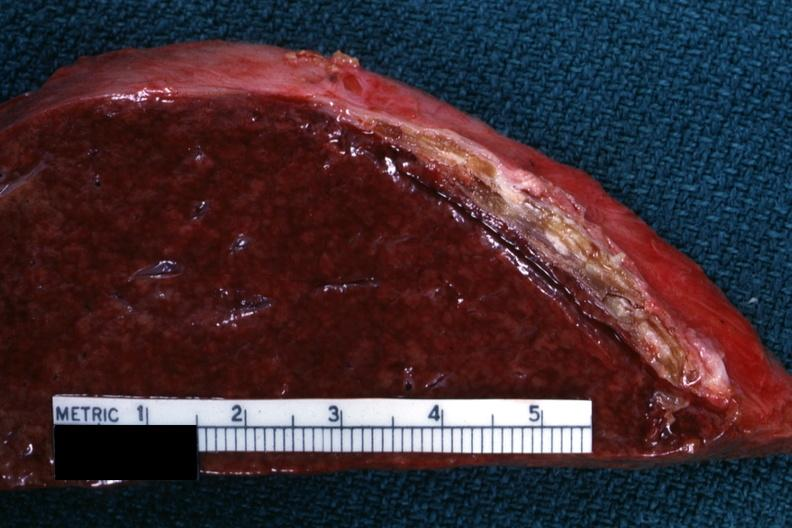s hematologic present?
Answer the question using a single word or phrase. Yes 